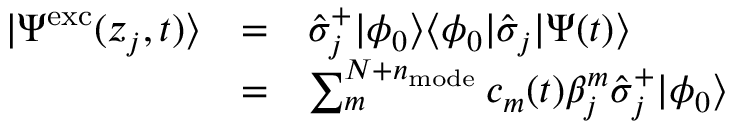Convert formula to latex. <formula><loc_0><loc_0><loc_500><loc_500>\begin{array} { c c l } { | \Psi ^ { e x c } ( z _ { j } , t ) \rangle } & { = } & { \hat { \sigma } _ { j } ^ { + } | \phi _ { 0 } \rangle \langle \phi _ { 0 } | \hat { \sigma } _ { j } | \Psi ( t ) \rangle } \\ & { = } & { \sum _ { m } ^ { N + n _ { m o d e } } c _ { m } ( t ) \beta _ { j } ^ { m } \hat { \sigma } _ { j } ^ { + } | \phi _ { 0 } \rangle } \end{array}</formula> 